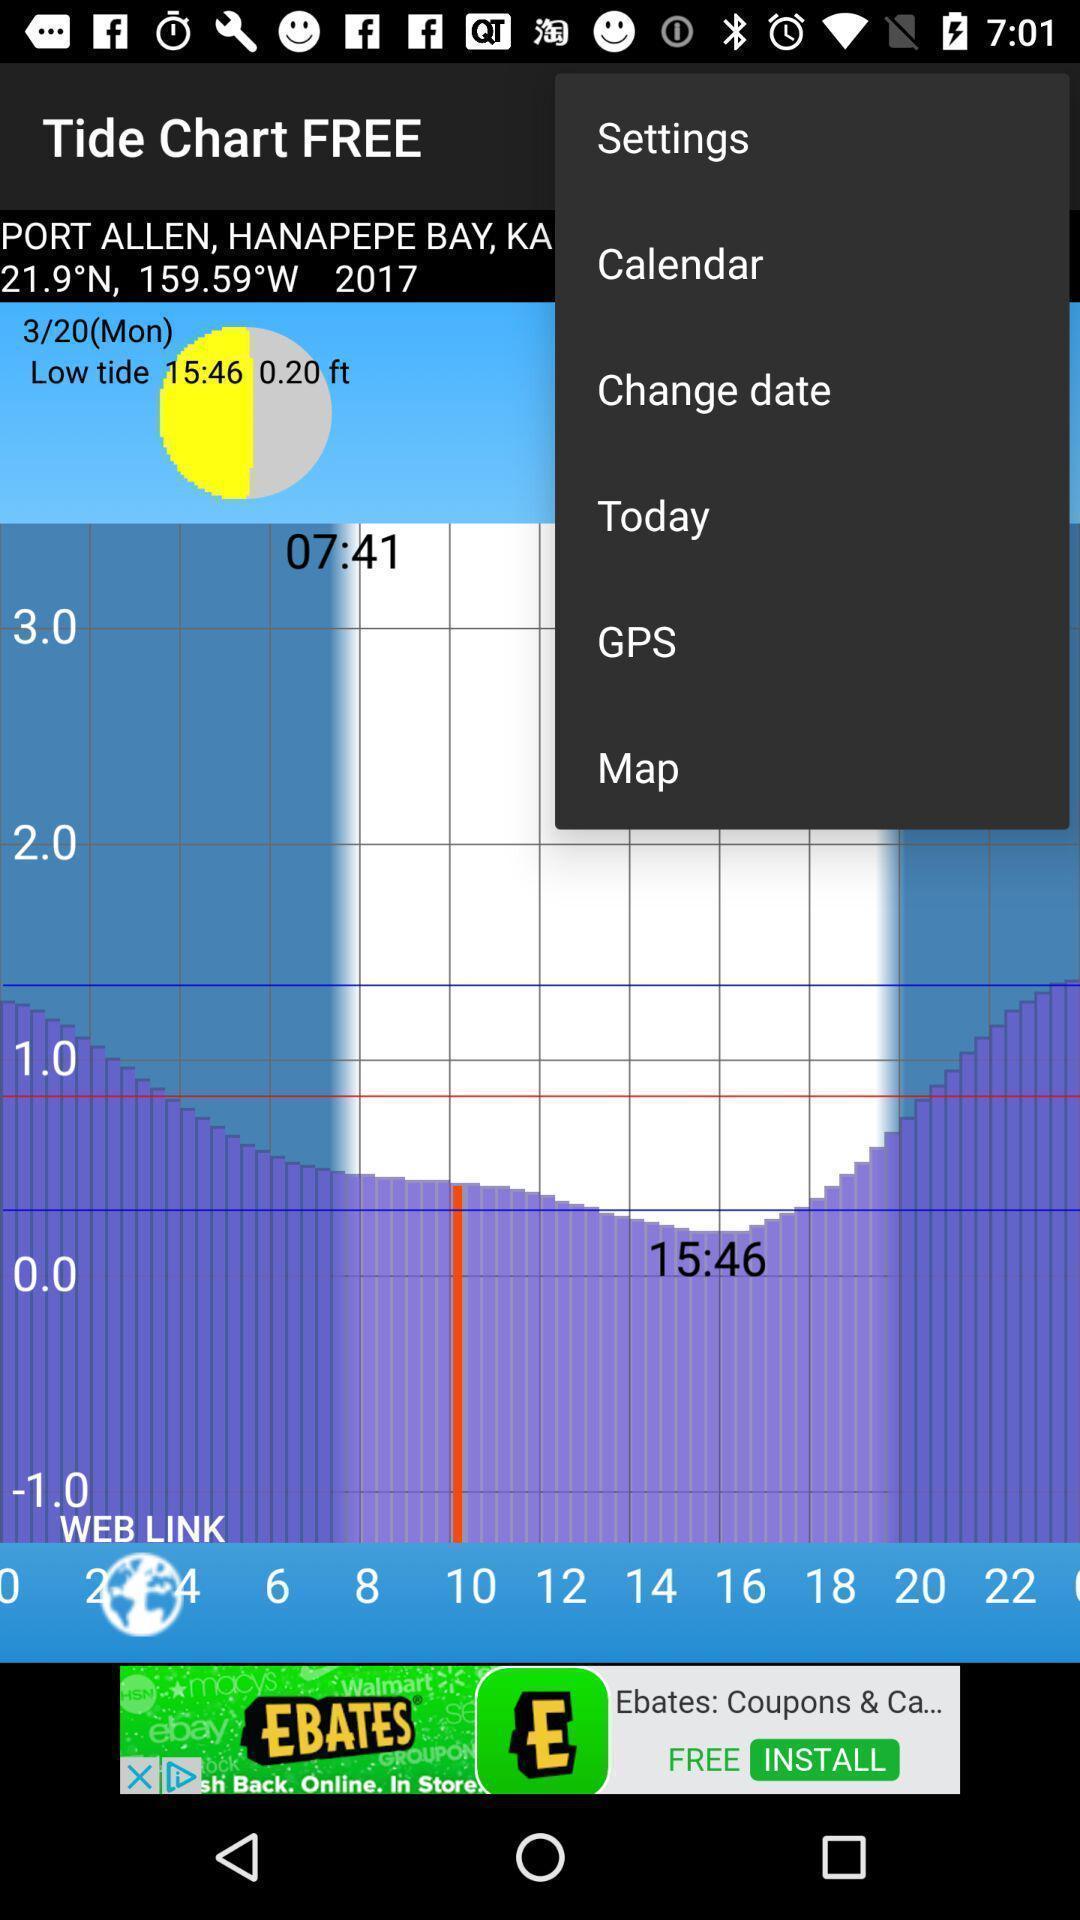Give me a narrative description of this picture. Tions menu in a weather app. 